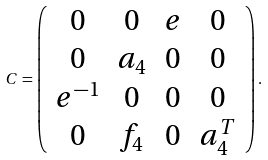Convert formula to latex. <formula><loc_0><loc_0><loc_500><loc_500>C = \left ( \begin{array} { c c c c } 0 & 0 & e & 0 \\ 0 & a _ { 4 } & 0 & 0 \\ e ^ { - 1 } & 0 & 0 & 0 \\ 0 & f _ { 4 } & 0 & a _ { 4 } ^ { T } \end{array} \right ) .</formula> 